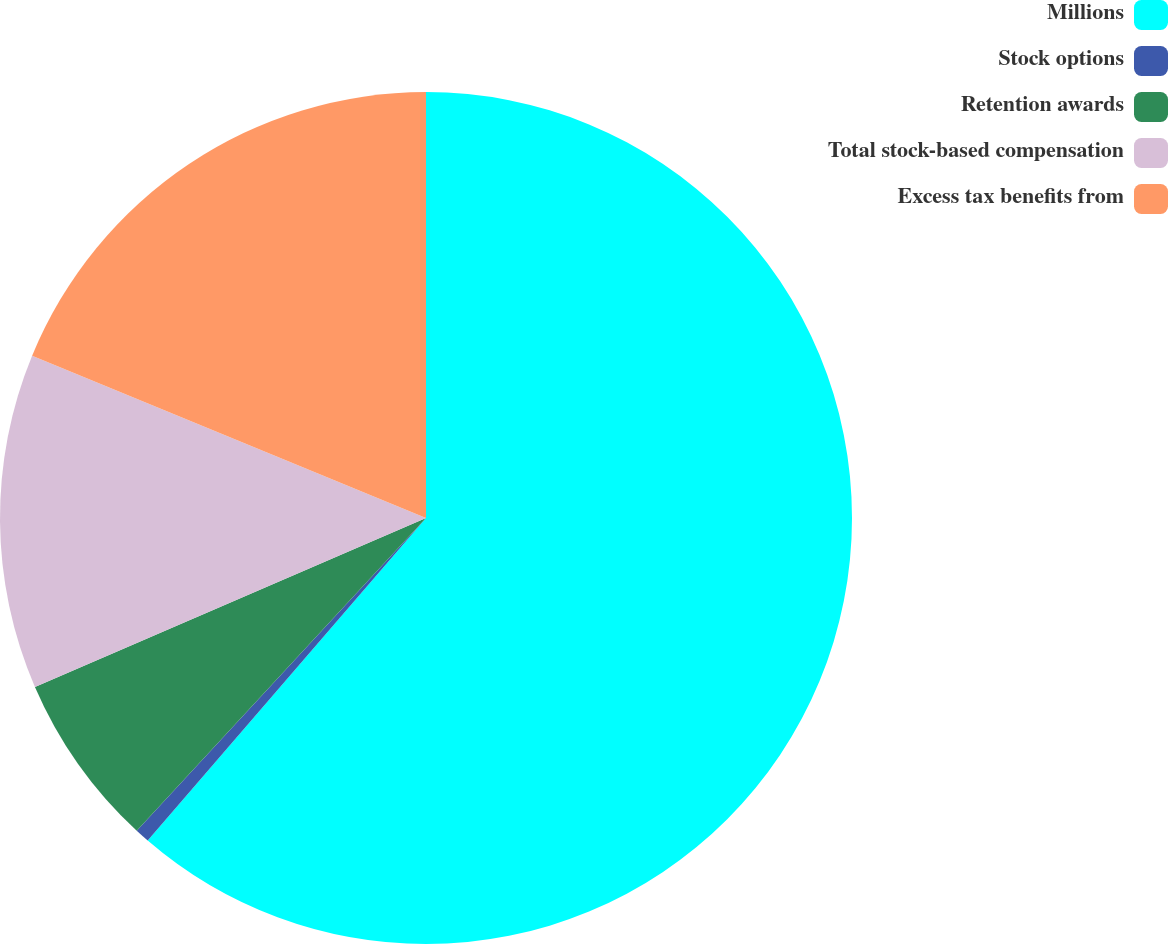Convert chart. <chart><loc_0><loc_0><loc_500><loc_500><pie_chart><fcel>Millions<fcel>Stock options<fcel>Retention awards<fcel>Total stock-based compensation<fcel>Excess tax benefits from<nl><fcel>61.33%<fcel>0.55%<fcel>6.63%<fcel>12.71%<fcel>18.78%<nl></chart> 